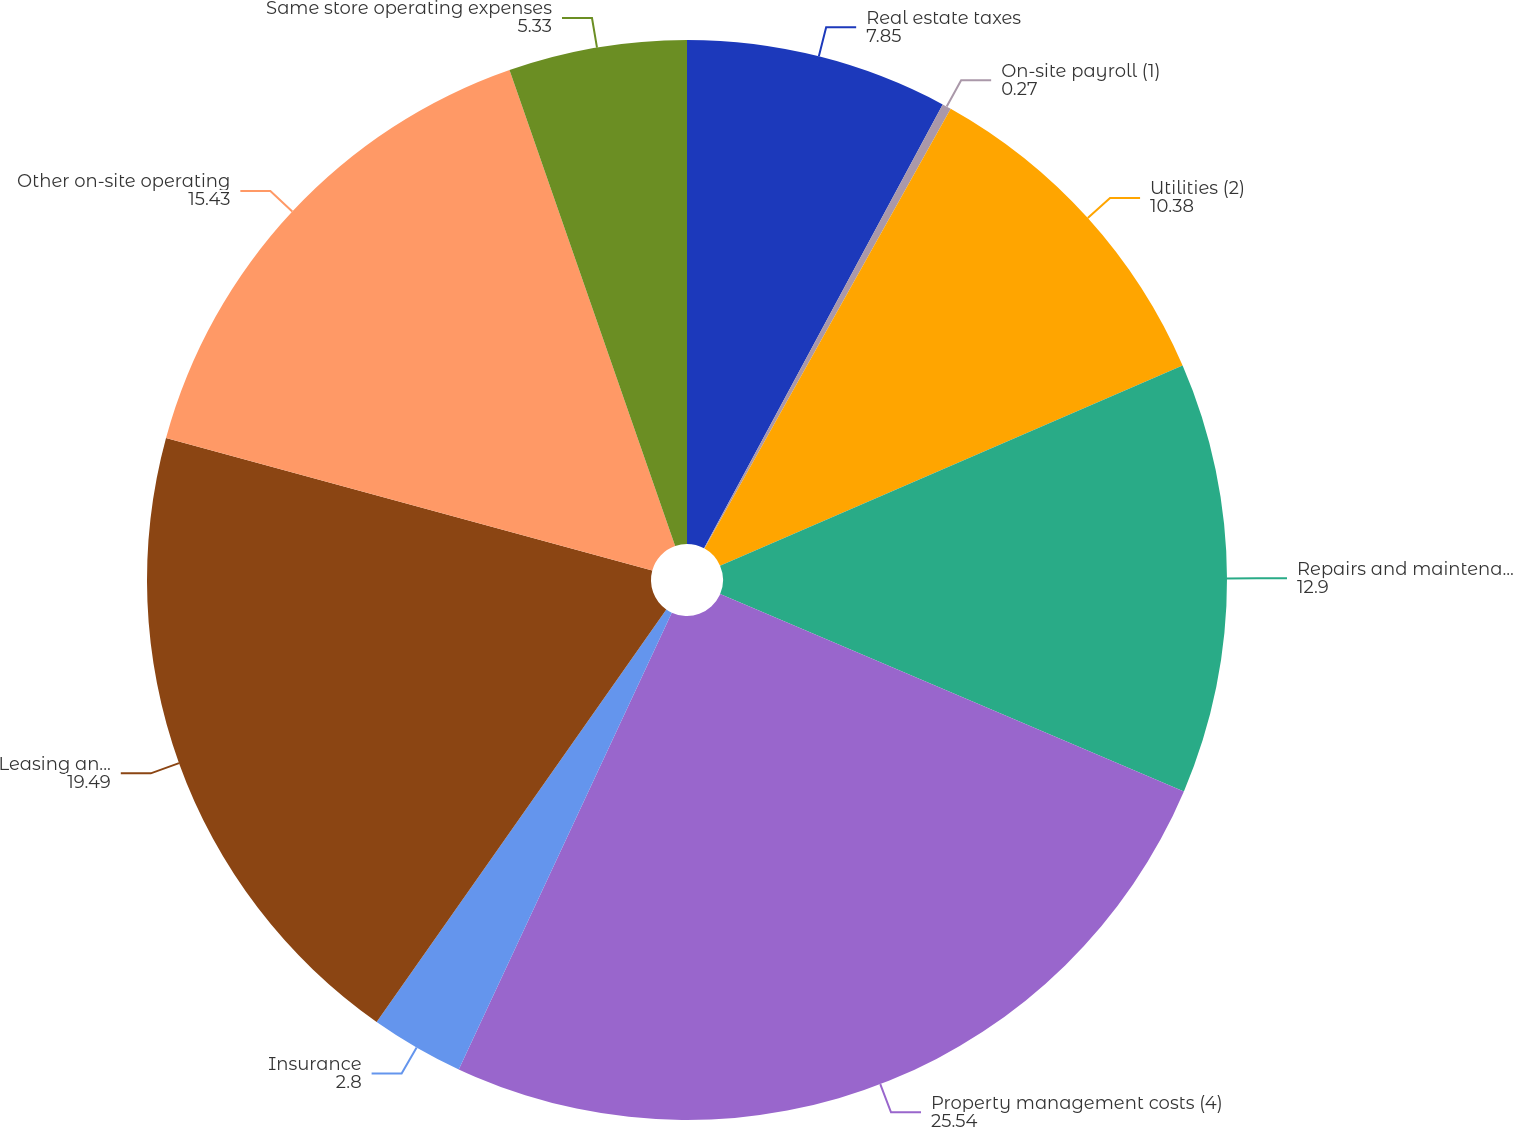<chart> <loc_0><loc_0><loc_500><loc_500><pie_chart><fcel>Real estate taxes<fcel>On-site payroll (1)<fcel>Utilities (2)<fcel>Repairs and maintenance (3)<fcel>Property management costs (4)<fcel>Insurance<fcel>Leasing and advertising<fcel>Other on-site operating<fcel>Same store operating expenses<nl><fcel>7.85%<fcel>0.27%<fcel>10.38%<fcel>12.9%<fcel>25.54%<fcel>2.8%<fcel>19.49%<fcel>15.43%<fcel>5.33%<nl></chart> 